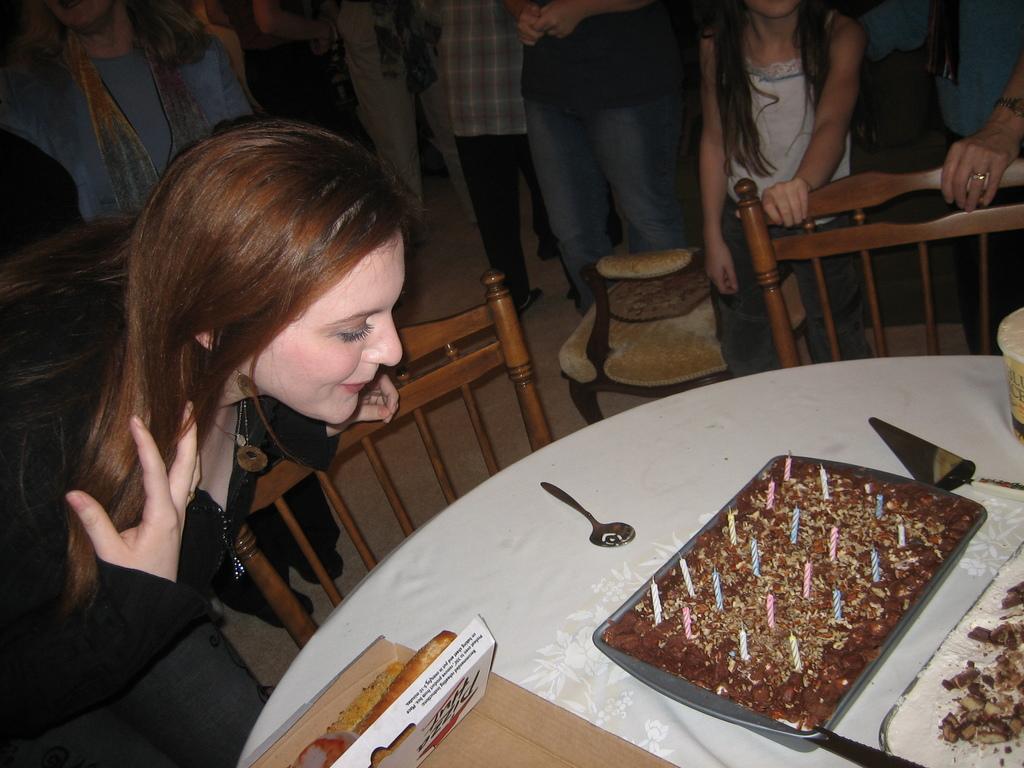How would you summarize this image in a sentence or two? In this image i can see a lady and few people standing in the background. I can see a table and a cake on it. I can also see a spoon and a box on the table. 